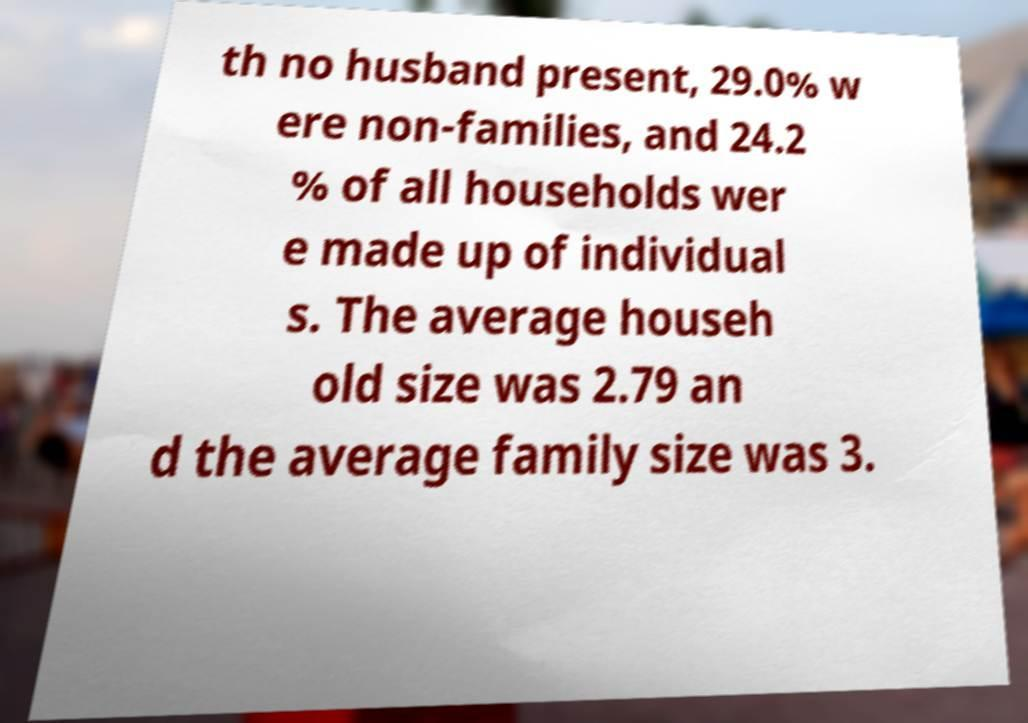Could you extract and type out the text from this image? th no husband present, 29.0% w ere non-families, and 24.2 % of all households wer e made up of individual s. The average househ old size was 2.79 an d the average family size was 3. 